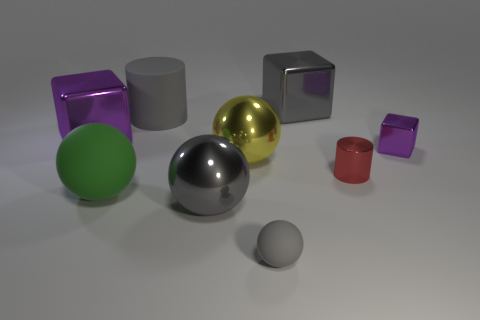What can you infer about the light source in this image based on the shadows? The light source appears to be located above and to the right of the objects, at a moderate angle, as indicated by the shadows being cast to the left and slightly forward of each object. The soft edges of the shadows suggest that the light source is not too close, providing a diffuse and even illumination. 